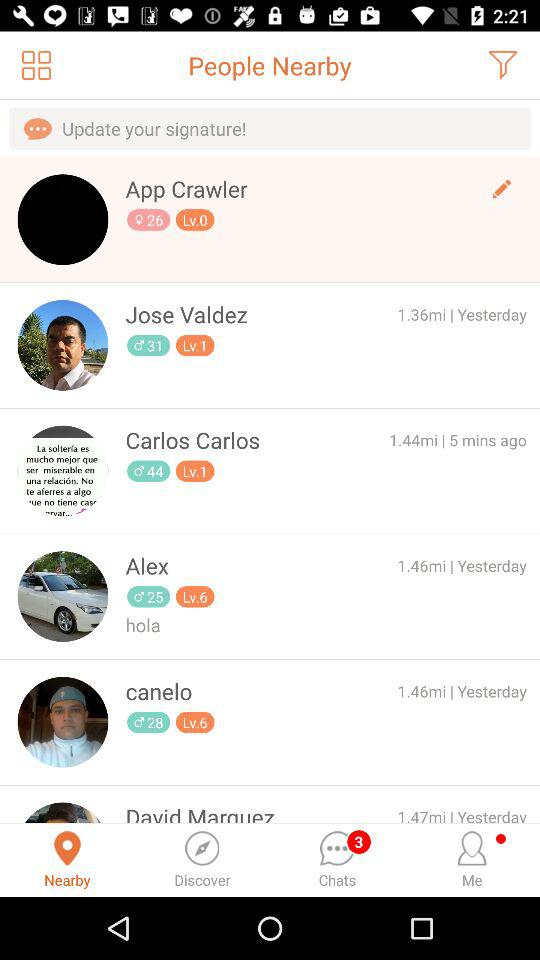How far is Jose Valdez? Jose Valdez is 1.36 miles away. 